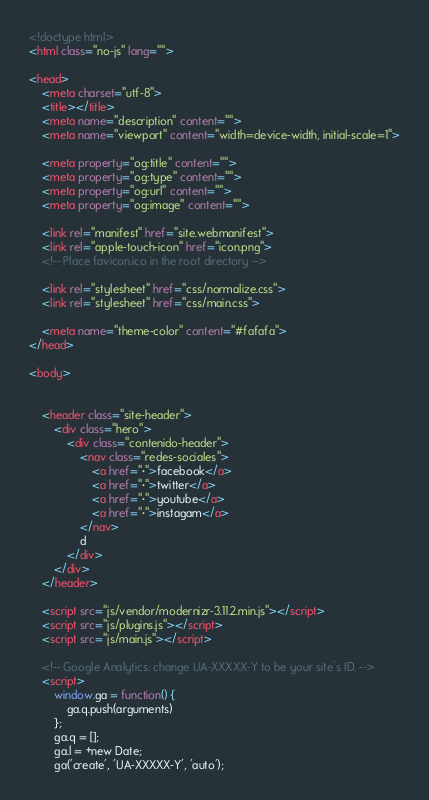<code> <loc_0><loc_0><loc_500><loc_500><_HTML_><!doctype html>
<html class="no-js" lang="">

<head>
    <meta charset="utf-8">
    <title></title>
    <meta name="description" content="">
    <meta name="viewport" content="width=device-width, initial-scale=1">

    <meta property="og:title" content="">
    <meta property="og:type" content="">
    <meta property="og:url" content="">
    <meta property="og:image" content="">

    <link rel="manifest" href="site.webmanifest">
    <link rel="apple-touch-icon" href="icon.png">
    <!-- Place favicon.ico in the root directory -->

    <link rel="stylesheet" href="css/normalize.css">
    <link rel="stylesheet" href="css/main.css">

    <meta name="theme-color" content="#fafafa">
</head>

<body>


    <header class="site-header">
        <div class="hero">
            <div class="contenido-header">
                <nav class="redes-sociales">
                    <a href="·">facebook</a>
                    <a href="·">twitter</a>
                    <a href="·">youtube</a>
                    <a href="·">instagam</a>
                </nav>
                d
            </div>
        </div>
    </header>

    <script src="js/vendor/modernizr-3.11.2.min.js"></script>
    <script src="js/plugins.js"></script>
    <script src="js/main.js"></script>

    <!-- Google Analytics: change UA-XXXXX-Y to be your site's ID. -->
    <script>
        window.ga = function() {
            ga.q.push(arguments)
        };
        ga.q = [];
        ga.l = +new Date;
        ga('create', 'UA-XXXXX-Y', 'auto');</code> 